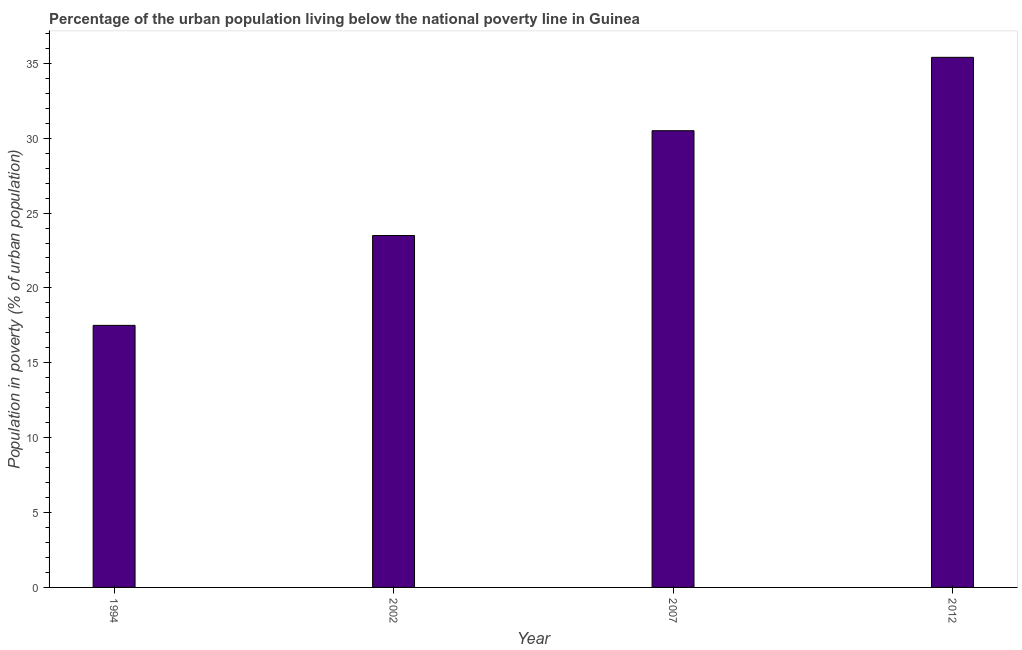Does the graph contain any zero values?
Keep it short and to the point. No. What is the title of the graph?
Make the answer very short. Percentage of the urban population living below the national poverty line in Guinea. What is the label or title of the Y-axis?
Your response must be concise. Population in poverty (% of urban population). What is the percentage of urban population living below poverty line in 1994?
Offer a terse response. 17.5. Across all years, what is the maximum percentage of urban population living below poverty line?
Your answer should be very brief. 35.4. What is the sum of the percentage of urban population living below poverty line?
Provide a short and direct response. 106.9. What is the difference between the percentage of urban population living below poverty line in 1994 and 2007?
Give a very brief answer. -13. What is the average percentage of urban population living below poverty line per year?
Keep it short and to the point. 26.73. What is the median percentage of urban population living below poverty line?
Provide a succinct answer. 27. What is the ratio of the percentage of urban population living below poverty line in 1994 to that in 2007?
Your answer should be compact. 0.57. Is the difference between the percentage of urban population living below poverty line in 1994 and 2012 greater than the difference between any two years?
Your answer should be very brief. Yes. What is the difference between the highest and the second highest percentage of urban population living below poverty line?
Keep it short and to the point. 4.9. Is the sum of the percentage of urban population living below poverty line in 2007 and 2012 greater than the maximum percentage of urban population living below poverty line across all years?
Provide a succinct answer. Yes. In how many years, is the percentage of urban population living below poverty line greater than the average percentage of urban population living below poverty line taken over all years?
Offer a terse response. 2. How many bars are there?
Provide a short and direct response. 4. How many years are there in the graph?
Your response must be concise. 4. What is the Population in poverty (% of urban population) in 1994?
Your answer should be very brief. 17.5. What is the Population in poverty (% of urban population) in 2002?
Your response must be concise. 23.5. What is the Population in poverty (% of urban population) in 2007?
Your response must be concise. 30.5. What is the Population in poverty (% of urban population) of 2012?
Your response must be concise. 35.4. What is the difference between the Population in poverty (% of urban population) in 1994 and 2007?
Your answer should be very brief. -13. What is the difference between the Population in poverty (% of urban population) in 1994 and 2012?
Your response must be concise. -17.9. What is the difference between the Population in poverty (% of urban population) in 2002 and 2007?
Your answer should be very brief. -7. What is the difference between the Population in poverty (% of urban population) in 2002 and 2012?
Your answer should be compact. -11.9. What is the difference between the Population in poverty (% of urban population) in 2007 and 2012?
Your response must be concise. -4.9. What is the ratio of the Population in poverty (% of urban population) in 1994 to that in 2002?
Provide a succinct answer. 0.74. What is the ratio of the Population in poverty (% of urban population) in 1994 to that in 2007?
Provide a succinct answer. 0.57. What is the ratio of the Population in poverty (% of urban population) in 1994 to that in 2012?
Keep it short and to the point. 0.49. What is the ratio of the Population in poverty (% of urban population) in 2002 to that in 2007?
Provide a short and direct response. 0.77. What is the ratio of the Population in poverty (% of urban population) in 2002 to that in 2012?
Your answer should be very brief. 0.66. What is the ratio of the Population in poverty (% of urban population) in 2007 to that in 2012?
Ensure brevity in your answer.  0.86. 